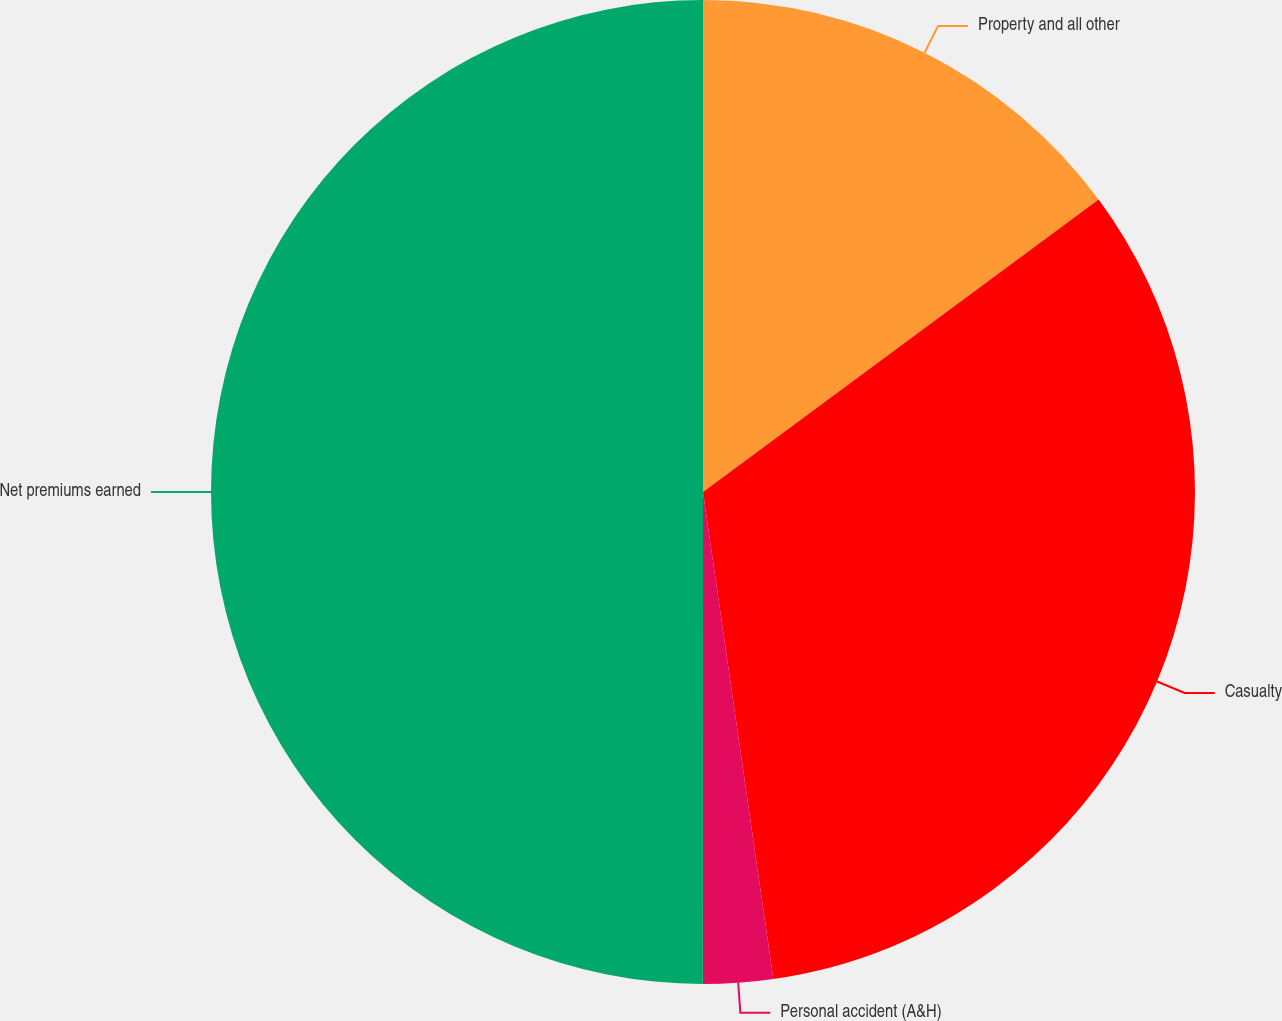Convert chart. <chart><loc_0><loc_0><loc_500><loc_500><pie_chart><fcel>Property and all other<fcel>Casualty<fcel>Personal accident (A&H)<fcel>Net premiums earned<nl><fcel>14.87%<fcel>32.85%<fcel>2.29%<fcel>50.0%<nl></chart> 